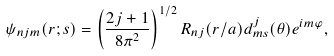<formula> <loc_0><loc_0><loc_500><loc_500>\psi _ { n j m } ( { r } ; { s } ) = \left ( \frac { 2 j + 1 } { 8 \pi ^ { 2 } } \right ) ^ { 1 / 2 } R _ { n j } ( { r } / { a } ) d ^ { j } _ { m s } ( \theta ) e ^ { i m \varphi } ,</formula> 